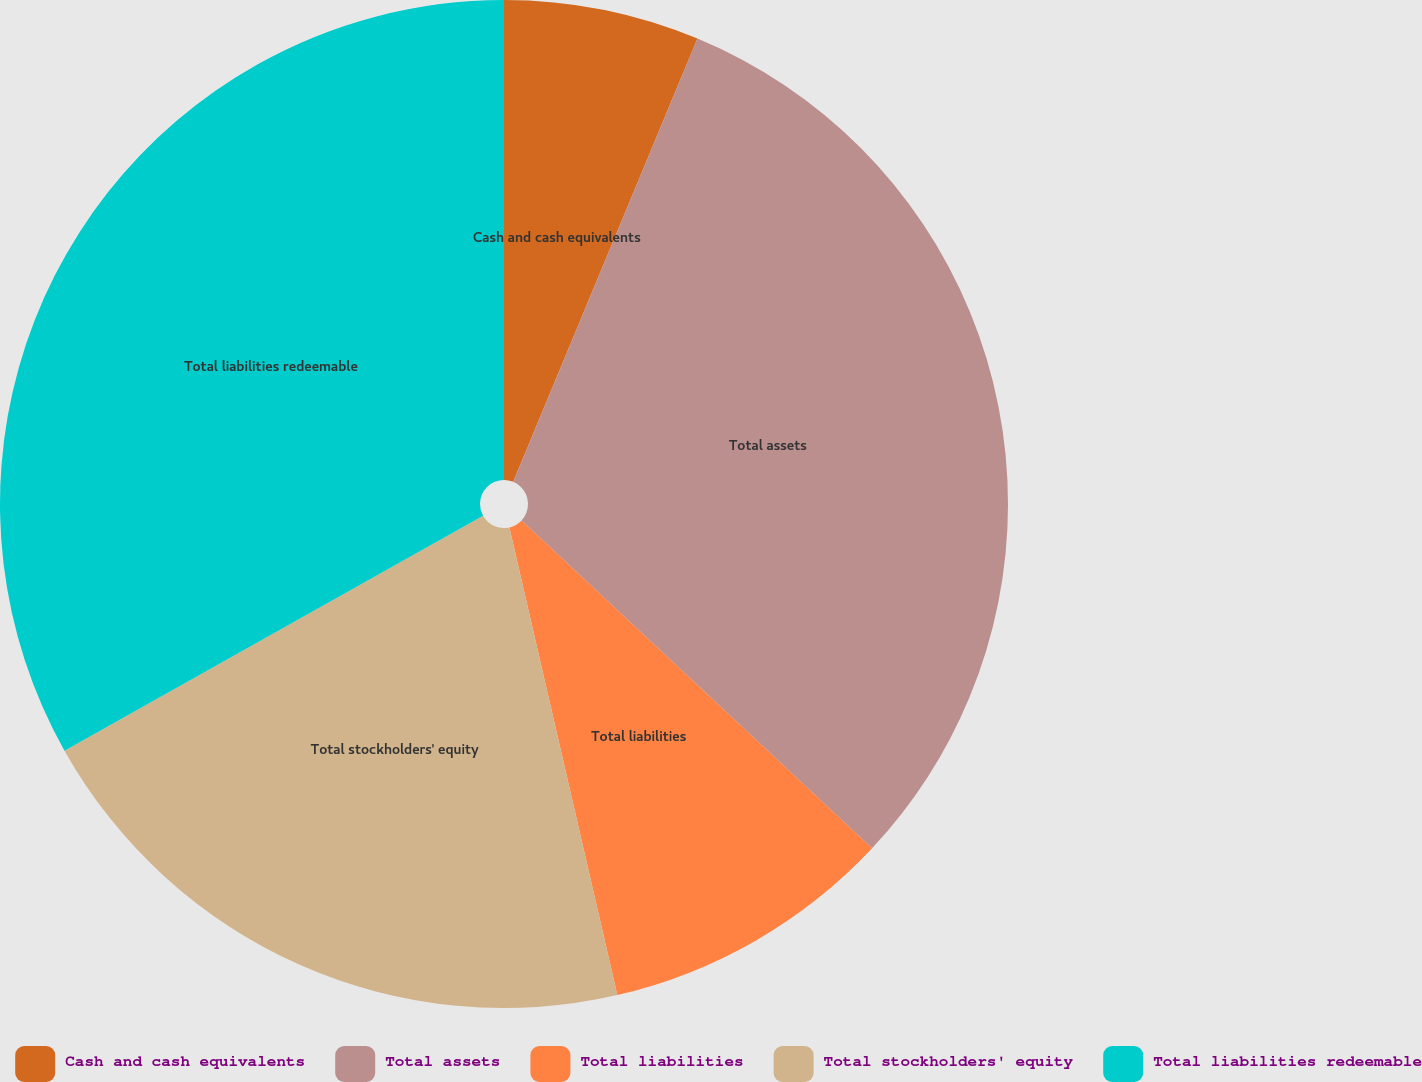<chart> <loc_0><loc_0><loc_500><loc_500><pie_chart><fcel>Cash and cash equivalents<fcel>Total assets<fcel>Total liabilities<fcel>Total stockholders' equity<fcel>Total liabilities redeemable<nl><fcel>6.27%<fcel>30.7%<fcel>9.42%<fcel>20.47%<fcel>33.14%<nl></chart> 